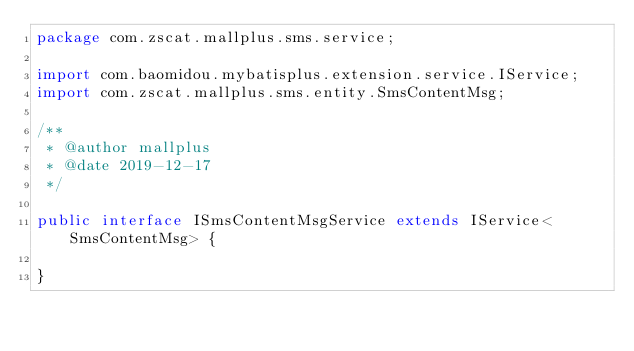<code> <loc_0><loc_0><loc_500><loc_500><_Java_>package com.zscat.mallplus.sms.service;

import com.baomidou.mybatisplus.extension.service.IService;
import com.zscat.mallplus.sms.entity.SmsContentMsg;

/**
 * @author mallplus
 * @date 2019-12-17
 */

public interface ISmsContentMsgService extends IService<SmsContentMsg> {

}
</code> 